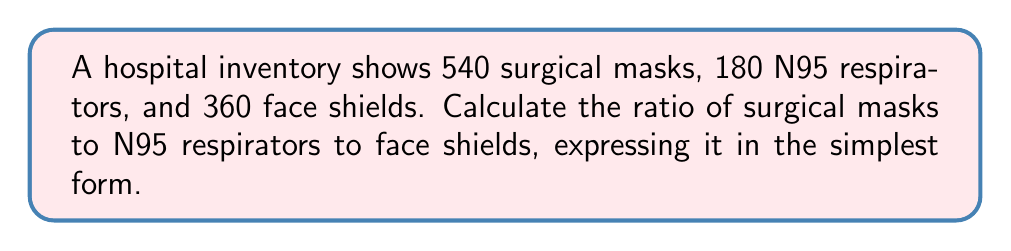Provide a solution to this math problem. To solve this problem, we'll follow these steps:

1) First, let's identify the quantities:
   Surgical masks: 540
   N95 respirators: 180
   Face shields: 360

2) To create a ratio, we list these numbers in the order specified:
   $540 : 180 : 360$

3) To simplify this ratio, we need to find the greatest common divisor (GCD) of all three numbers:
   $GCD(540, 180, 360) = 60$

4) Now, we divide each number by the GCD:
   
   $\frac{540}{60} : \frac{180}{60} : \frac{360}{60}$

5) This simplifies to:
   $9 : 3 : 6$

Therefore, the simplified ratio of surgical masks to N95 respirators to face shields is $9:3:6$.
Answer: $9:3:6$ 